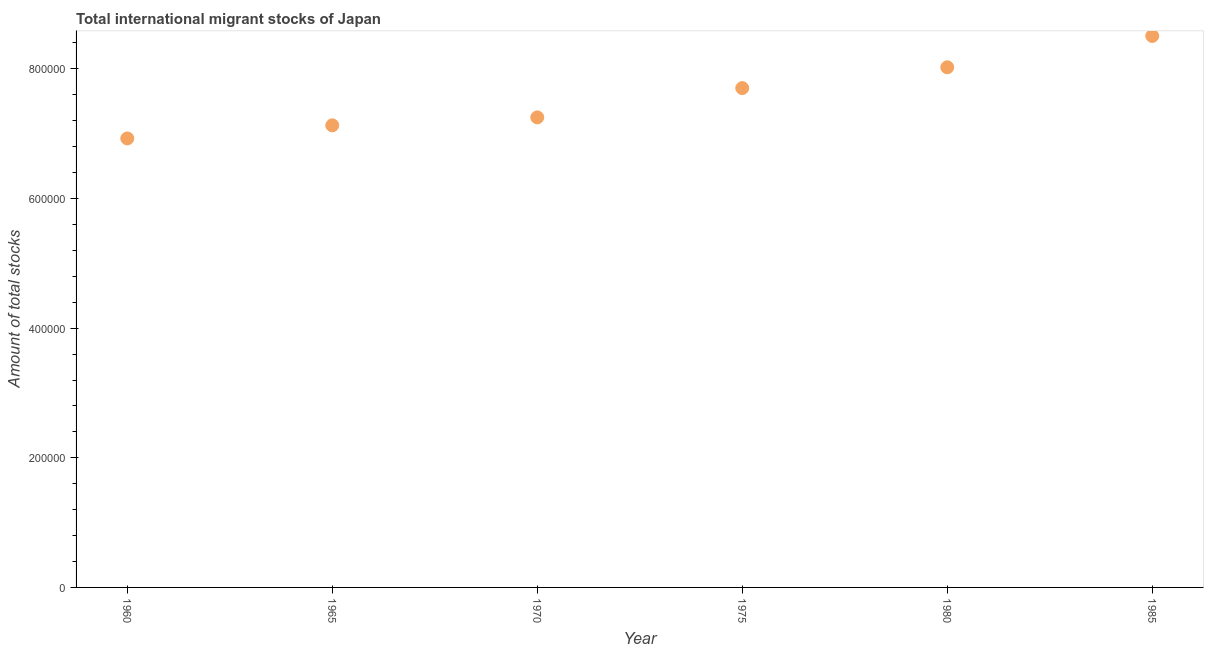What is the total number of international migrant stock in 1965?
Make the answer very short. 7.13e+05. Across all years, what is the maximum total number of international migrant stock?
Give a very brief answer. 8.51e+05. Across all years, what is the minimum total number of international migrant stock?
Your response must be concise. 6.93e+05. In which year was the total number of international migrant stock maximum?
Your response must be concise. 1985. In which year was the total number of international migrant stock minimum?
Provide a short and direct response. 1960. What is the sum of the total number of international migrant stock?
Your answer should be compact. 4.55e+06. What is the difference between the total number of international migrant stock in 1965 and 1975?
Offer a very short reply. -5.75e+04. What is the average total number of international migrant stock per year?
Ensure brevity in your answer.  7.59e+05. What is the median total number of international migrant stock?
Ensure brevity in your answer.  7.48e+05. In how many years, is the total number of international migrant stock greater than 800000 ?
Your answer should be compact. 2. What is the ratio of the total number of international migrant stock in 1965 to that in 1975?
Give a very brief answer. 0.93. Is the total number of international migrant stock in 1970 less than that in 1985?
Your answer should be very brief. Yes. What is the difference between the highest and the second highest total number of international migrant stock?
Provide a succinct answer. 4.84e+04. Is the sum of the total number of international migrant stock in 1960 and 1980 greater than the maximum total number of international migrant stock across all years?
Offer a very short reply. Yes. What is the difference between the highest and the lowest total number of international migrant stock?
Offer a terse response. 1.58e+05. How many dotlines are there?
Your answer should be very brief. 1. How many years are there in the graph?
Provide a short and direct response. 6. What is the title of the graph?
Make the answer very short. Total international migrant stocks of Japan. What is the label or title of the X-axis?
Your answer should be compact. Year. What is the label or title of the Y-axis?
Your answer should be compact. Amount of total stocks. What is the Amount of total stocks in 1960?
Keep it short and to the point. 6.93e+05. What is the Amount of total stocks in 1965?
Your answer should be very brief. 7.13e+05. What is the Amount of total stocks in 1970?
Your response must be concise. 7.25e+05. What is the Amount of total stocks in 1975?
Ensure brevity in your answer.  7.70e+05. What is the Amount of total stocks in 1980?
Ensure brevity in your answer.  8.02e+05. What is the Amount of total stocks in 1985?
Offer a very short reply. 8.51e+05. What is the difference between the Amount of total stocks in 1960 and 1965?
Make the answer very short. -2.02e+04. What is the difference between the Amount of total stocks in 1960 and 1970?
Your answer should be compact. -3.25e+04. What is the difference between the Amount of total stocks in 1960 and 1975?
Give a very brief answer. -7.77e+04. What is the difference between the Amount of total stocks in 1960 and 1980?
Your answer should be very brief. -1.10e+05. What is the difference between the Amount of total stocks in 1960 and 1985?
Your answer should be very brief. -1.58e+05. What is the difference between the Amount of total stocks in 1965 and 1970?
Offer a terse response. -1.23e+04. What is the difference between the Amount of total stocks in 1965 and 1975?
Make the answer very short. -5.75e+04. What is the difference between the Amount of total stocks in 1965 and 1980?
Your response must be concise. -8.96e+04. What is the difference between the Amount of total stocks in 1965 and 1985?
Make the answer very short. -1.38e+05. What is the difference between the Amount of total stocks in 1970 and 1975?
Keep it short and to the point. -4.52e+04. What is the difference between the Amount of total stocks in 1970 and 1980?
Give a very brief answer. -7.73e+04. What is the difference between the Amount of total stocks in 1970 and 1985?
Your answer should be very brief. -1.26e+05. What is the difference between the Amount of total stocks in 1975 and 1980?
Give a very brief answer. -3.21e+04. What is the difference between the Amount of total stocks in 1975 and 1985?
Offer a very short reply. -8.04e+04. What is the difference between the Amount of total stocks in 1980 and 1985?
Your answer should be very brief. -4.84e+04. What is the ratio of the Amount of total stocks in 1960 to that in 1965?
Give a very brief answer. 0.97. What is the ratio of the Amount of total stocks in 1960 to that in 1970?
Offer a very short reply. 0.95. What is the ratio of the Amount of total stocks in 1960 to that in 1975?
Keep it short and to the point. 0.9. What is the ratio of the Amount of total stocks in 1960 to that in 1980?
Offer a very short reply. 0.86. What is the ratio of the Amount of total stocks in 1960 to that in 1985?
Keep it short and to the point. 0.81. What is the ratio of the Amount of total stocks in 1965 to that in 1970?
Give a very brief answer. 0.98. What is the ratio of the Amount of total stocks in 1965 to that in 1975?
Keep it short and to the point. 0.93. What is the ratio of the Amount of total stocks in 1965 to that in 1980?
Provide a succinct answer. 0.89. What is the ratio of the Amount of total stocks in 1965 to that in 1985?
Your response must be concise. 0.84. What is the ratio of the Amount of total stocks in 1970 to that in 1975?
Give a very brief answer. 0.94. What is the ratio of the Amount of total stocks in 1970 to that in 1980?
Your response must be concise. 0.9. What is the ratio of the Amount of total stocks in 1970 to that in 1985?
Offer a terse response. 0.85. What is the ratio of the Amount of total stocks in 1975 to that in 1985?
Offer a very short reply. 0.91. What is the ratio of the Amount of total stocks in 1980 to that in 1985?
Make the answer very short. 0.94. 